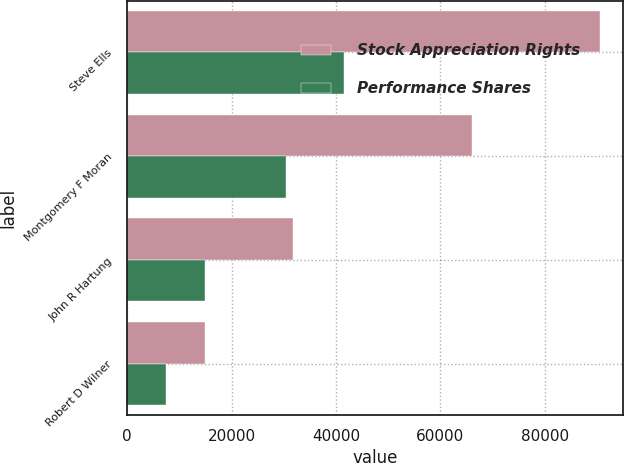Convert chart. <chart><loc_0><loc_0><loc_500><loc_500><stacked_bar_chart><ecel><fcel>Steve Ells<fcel>Montgomery F Moran<fcel>John R Hartung<fcel>Robert D Wilner<nl><fcel>Stock Appreciation Rights<fcel>90500<fcel>66000<fcel>31700<fcel>15000<nl><fcel>Performance Shares<fcel>41600<fcel>30400<fcel>15000<fcel>7500<nl></chart> 